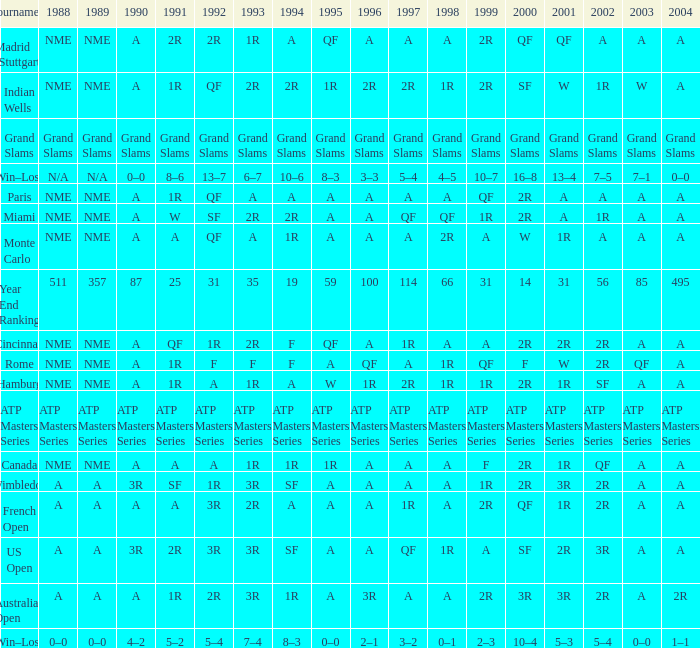What shows for 202 when the 1994 is A, the 1989 is NME, and the 199 is 2R? A. 